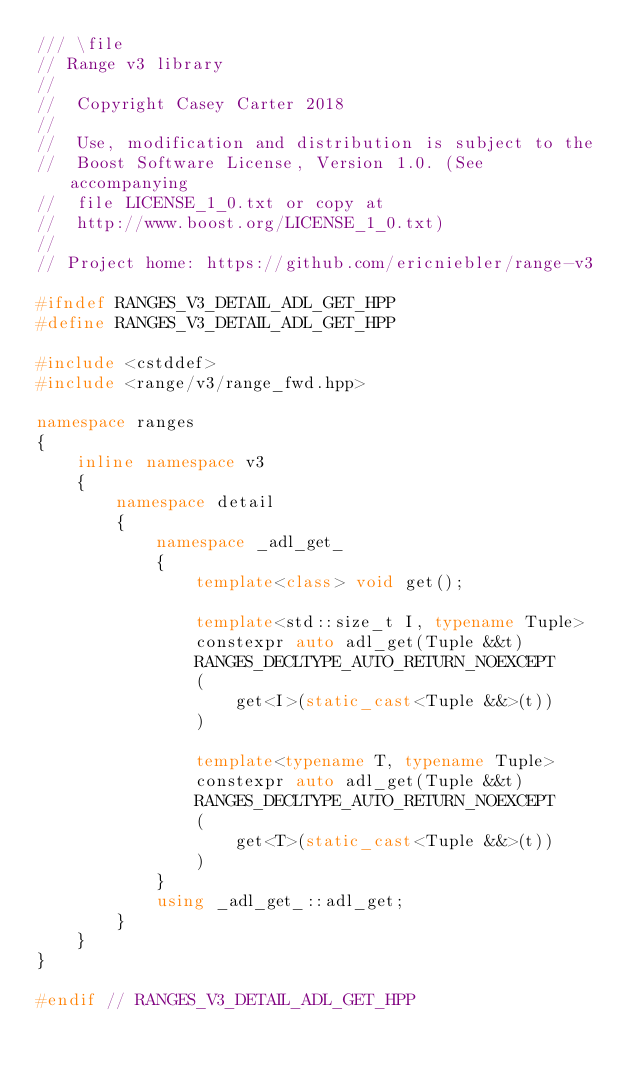<code> <loc_0><loc_0><loc_500><loc_500><_C++_>/// \file
// Range v3 library
//
//  Copyright Casey Carter 2018
//
//  Use, modification and distribution is subject to the
//  Boost Software License, Version 1.0. (See accompanying
//  file LICENSE_1_0.txt or copy at
//  http://www.boost.org/LICENSE_1_0.txt)
//
// Project home: https://github.com/ericniebler/range-v3

#ifndef RANGES_V3_DETAIL_ADL_GET_HPP
#define RANGES_V3_DETAIL_ADL_GET_HPP

#include <cstddef>
#include <range/v3/range_fwd.hpp>

namespace ranges
{
    inline namespace v3
    {
        namespace detail
        {
            namespace _adl_get_
            {
                template<class> void get();

                template<std::size_t I, typename Tuple>
                constexpr auto adl_get(Tuple &&t)
                RANGES_DECLTYPE_AUTO_RETURN_NOEXCEPT
                (
                    get<I>(static_cast<Tuple &&>(t))
                )

                template<typename T, typename Tuple>
                constexpr auto adl_get(Tuple &&t)
                RANGES_DECLTYPE_AUTO_RETURN_NOEXCEPT
                (
                    get<T>(static_cast<Tuple &&>(t))
                )
            }
            using _adl_get_::adl_get;
        }
    }
}

#endif // RANGES_V3_DETAIL_ADL_GET_HPP
</code> 